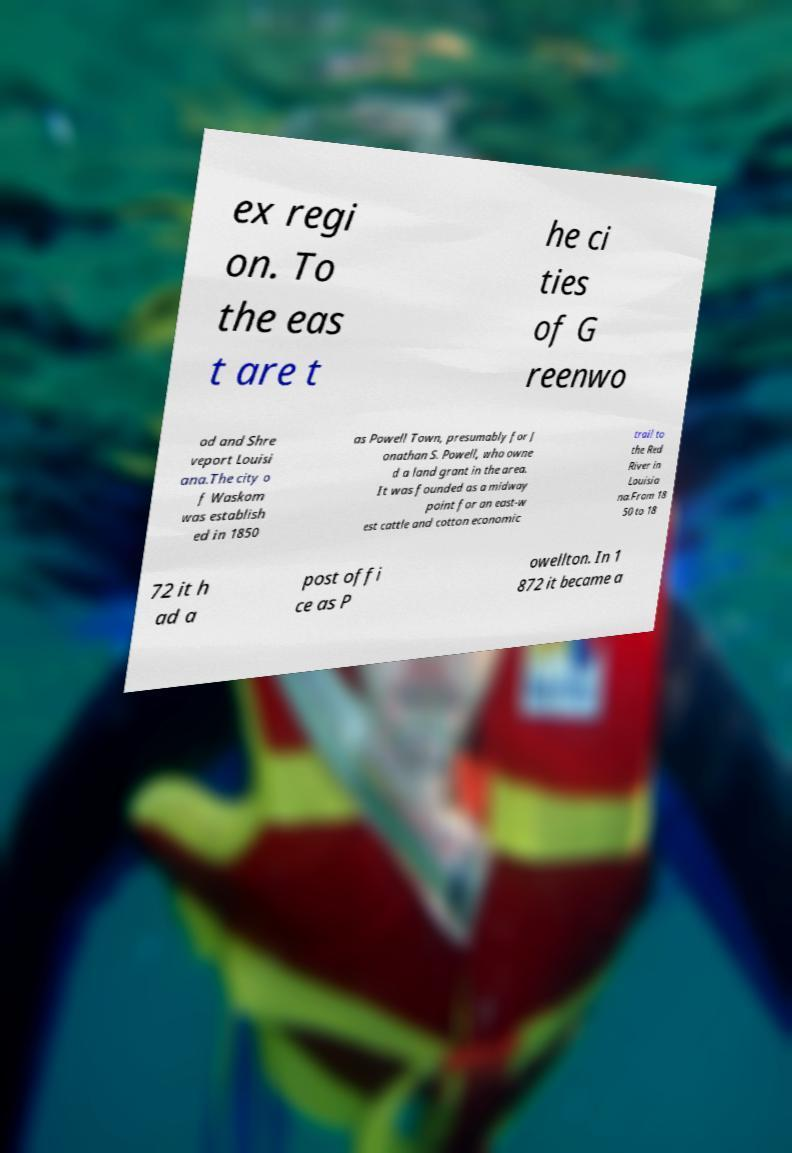Could you extract and type out the text from this image? ex regi on. To the eas t are t he ci ties of G reenwo od and Shre veport Louisi ana.The city o f Waskom was establish ed in 1850 as Powell Town, presumably for J onathan S. Powell, who owne d a land grant in the area. It was founded as a midway point for an east-w est cattle and cotton economic trail to the Red River in Louisia na.From 18 50 to 18 72 it h ad a post offi ce as P owellton. In 1 872 it became a 